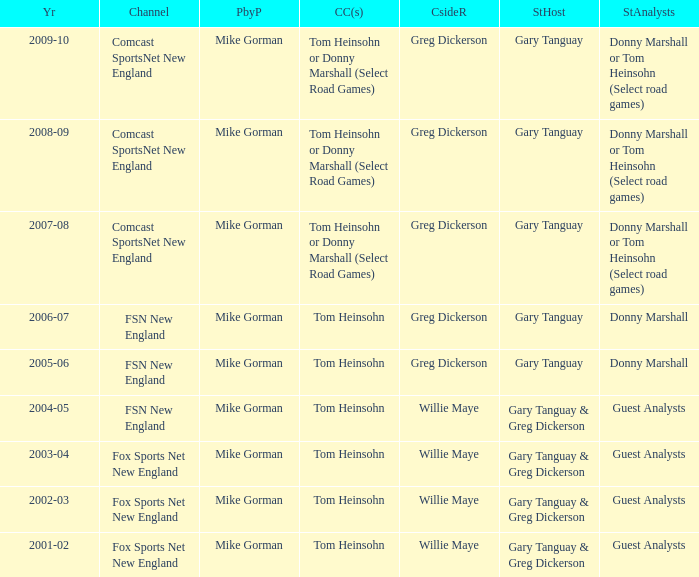Who are the studio analysts for the year 2008-09? Donny Marshall or Tom Heinsohn (Select road games). 